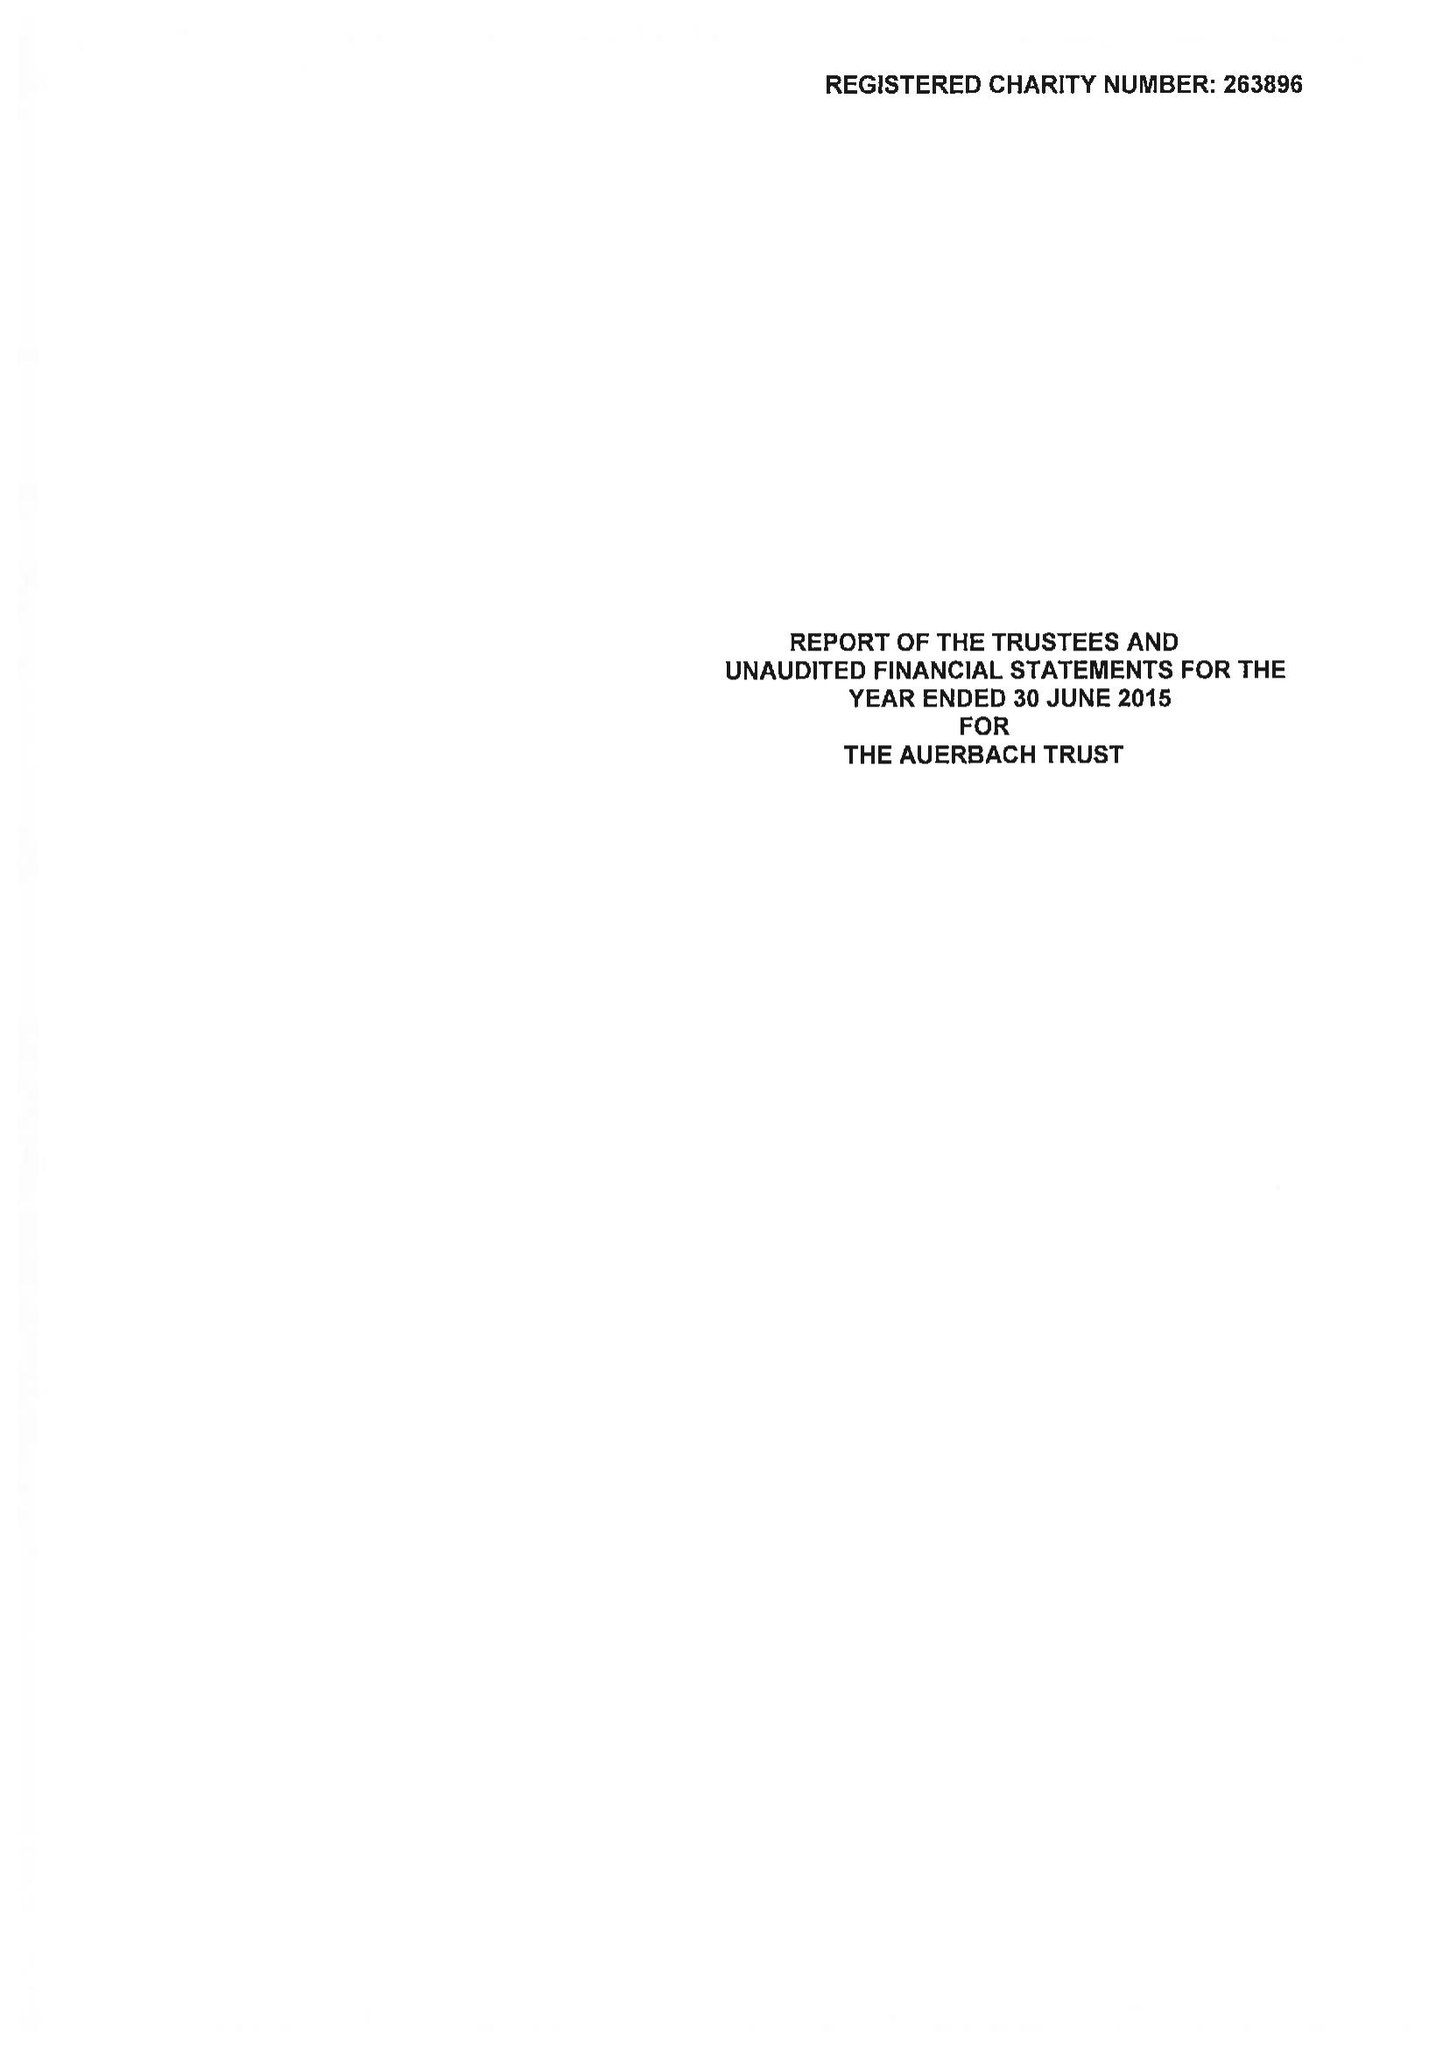What is the value for the charity_name?
Answer the question using a single word or phrase. The Auerbach Trust 